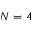<formula> <loc_0><loc_0><loc_500><loc_500>N = 4</formula> 